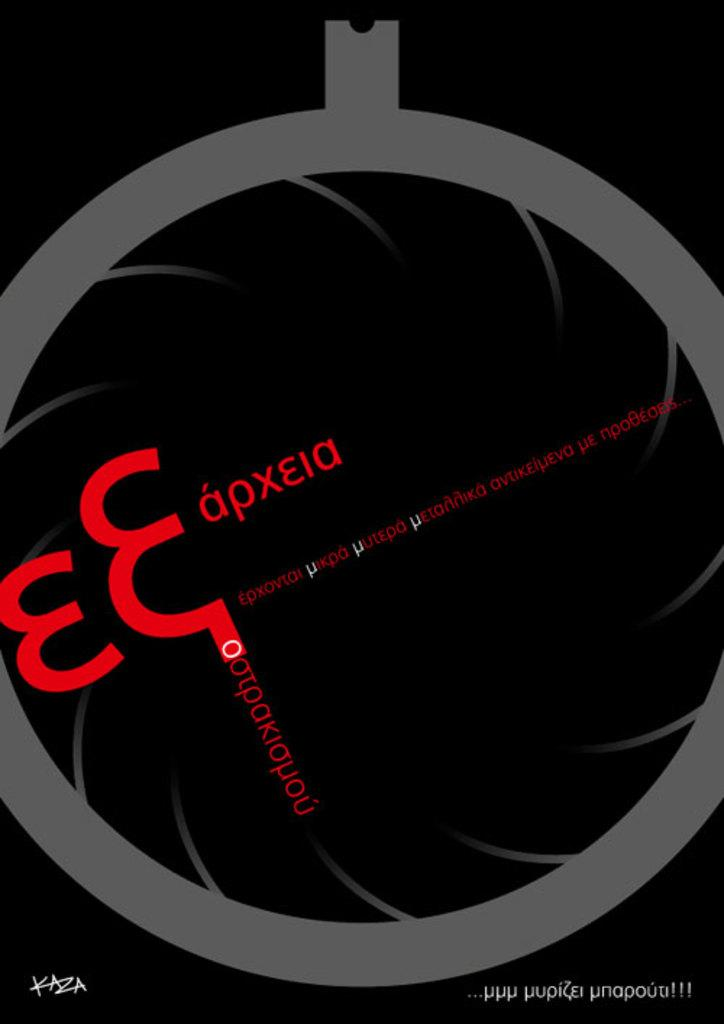<image>
Render a clear and concise summary of the photo. Foreign language E Eapxeia product in red lettering on a black and gray background. 